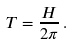Convert formula to latex. <formula><loc_0><loc_0><loc_500><loc_500>T = \frac { H } { 2 \pi } \, .</formula> 